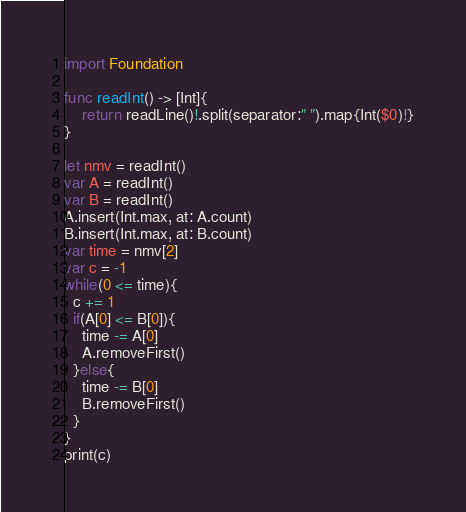<code> <loc_0><loc_0><loc_500><loc_500><_Swift_>import Foundation

func readInt() -> [Int]{
    return readLine()!.split(separator:" ").map{Int($0)!}
}

let nmv = readInt()
var A = readInt()
var B = readInt()
A.insert(Int.max, at: A.count)
B.insert(Int.max, at: B.count)
var time = nmv[2]
var c = -1
while(0 <= time){
  c += 1
  if(A[0] <= B[0]){
    time -= A[0]
    A.removeFirst()
  }else{
    time -= B[0]
    B.removeFirst()
  }
}
print(c)</code> 